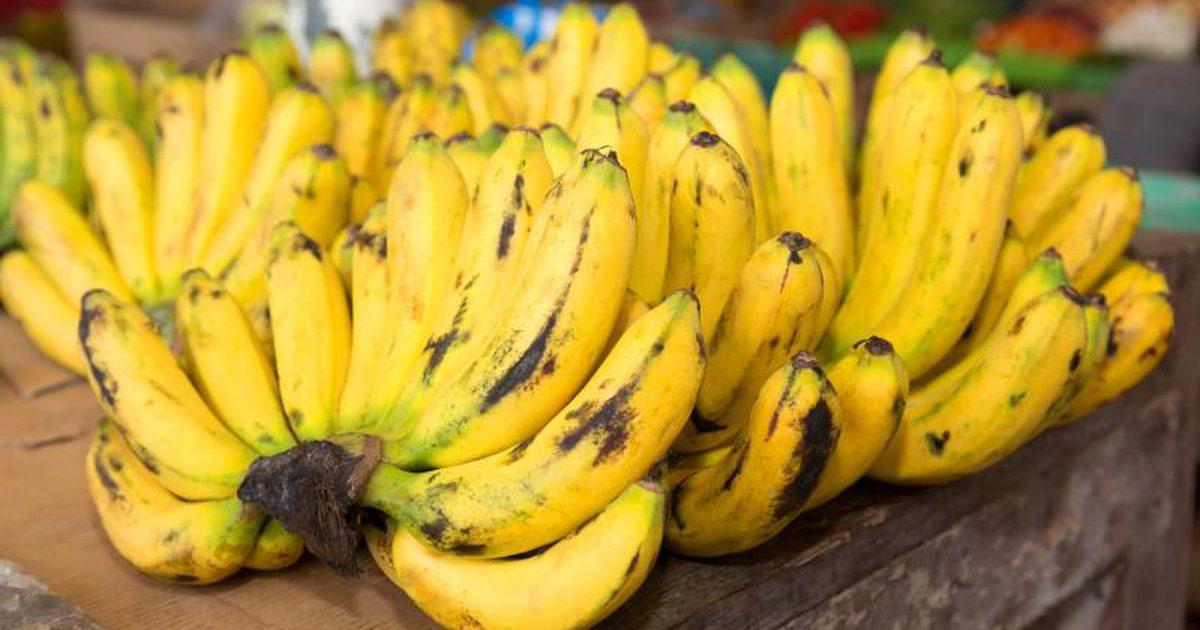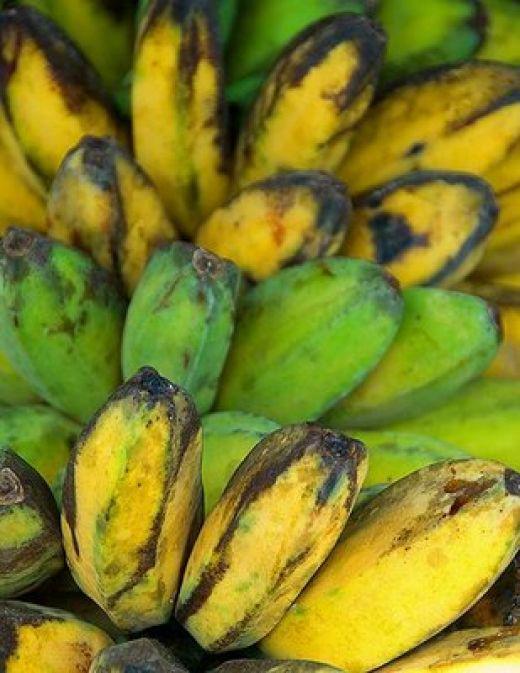The first image is the image on the left, the second image is the image on the right. Assess this claim about the two images: "One image features a pineapple, bananas and other fruit along with a beverage in a glass, and the other image features only bunches of bananas.". Correct or not? Answer yes or no. No. The first image is the image on the left, the second image is the image on the right. Considering the images on both sides, is "One image has only bananas and the other has fruit and a fruit smoothie." valid? Answer yes or no. No. 